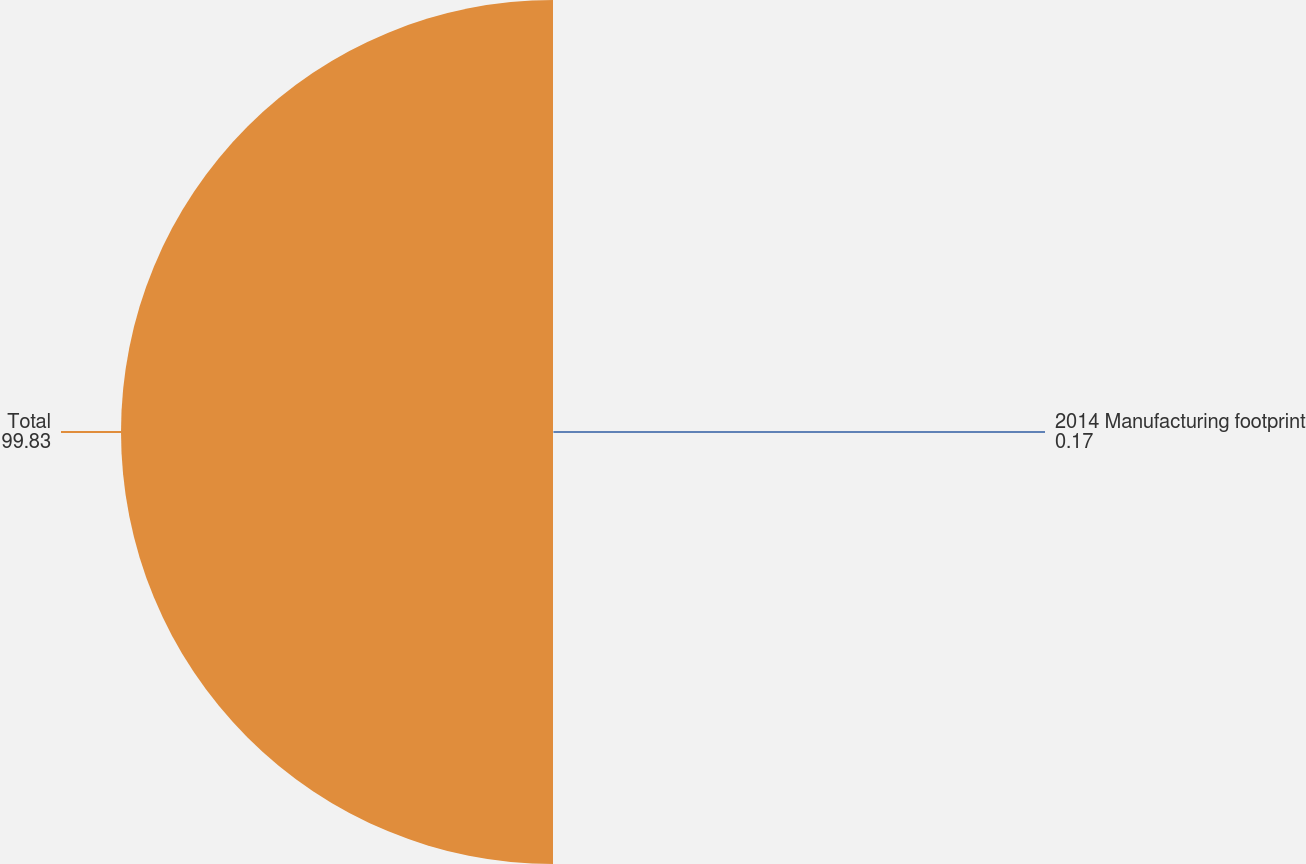Convert chart. <chart><loc_0><loc_0><loc_500><loc_500><pie_chart><fcel>2014 Manufacturing footprint<fcel>Total<nl><fcel>0.17%<fcel>99.83%<nl></chart> 